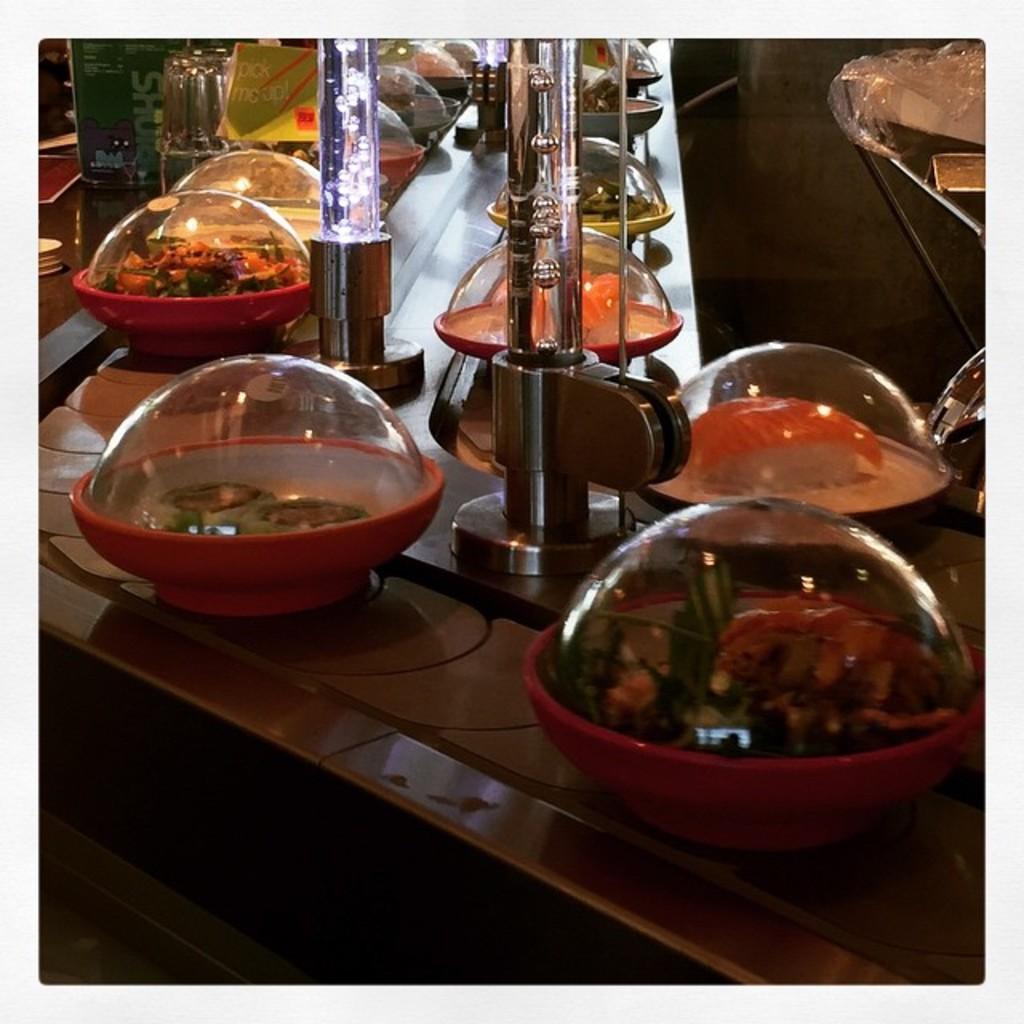Describe this image in one or two sentences. In this image, we can see some dishes and glass tubes on the table. 